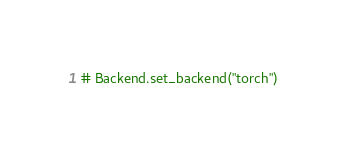<code> <loc_0><loc_0><loc_500><loc_500><_Python_>
# Backend.set_backend("torch")
</code> 